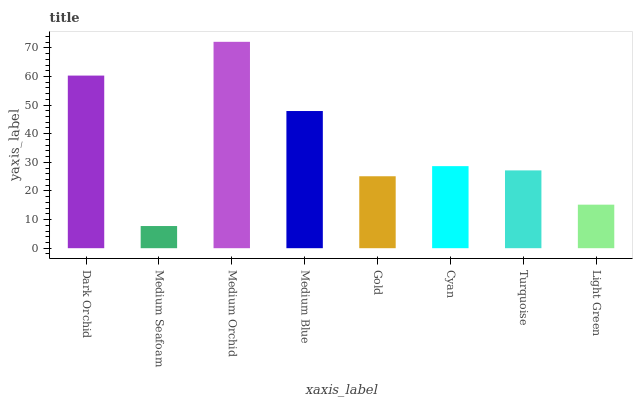Is Medium Seafoam the minimum?
Answer yes or no. Yes. Is Medium Orchid the maximum?
Answer yes or no. Yes. Is Medium Orchid the minimum?
Answer yes or no. No. Is Medium Seafoam the maximum?
Answer yes or no. No. Is Medium Orchid greater than Medium Seafoam?
Answer yes or no. Yes. Is Medium Seafoam less than Medium Orchid?
Answer yes or no. Yes. Is Medium Seafoam greater than Medium Orchid?
Answer yes or no. No. Is Medium Orchid less than Medium Seafoam?
Answer yes or no. No. Is Cyan the high median?
Answer yes or no. Yes. Is Turquoise the low median?
Answer yes or no. Yes. Is Medium Seafoam the high median?
Answer yes or no. No. Is Light Green the low median?
Answer yes or no. No. 